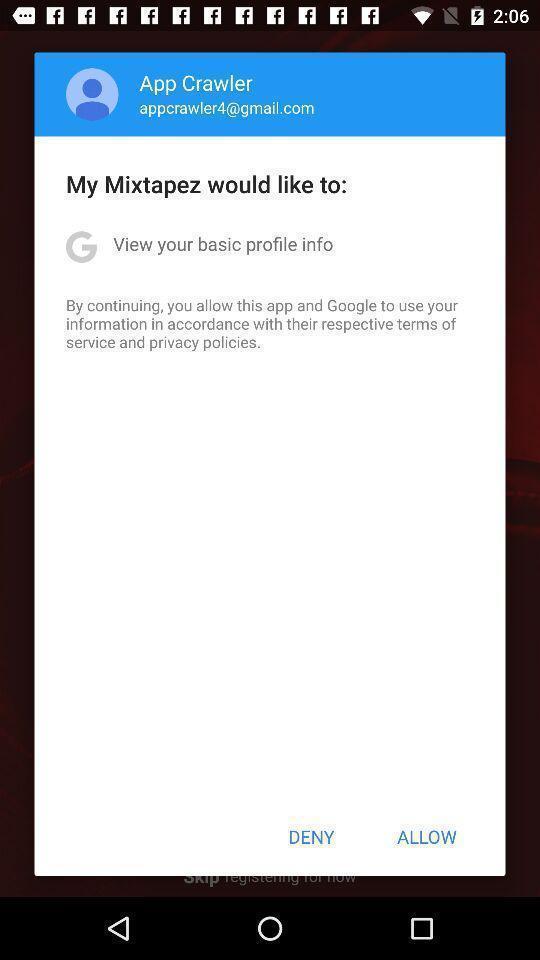What can you discern from this picture? Popup displaying options to choose. 